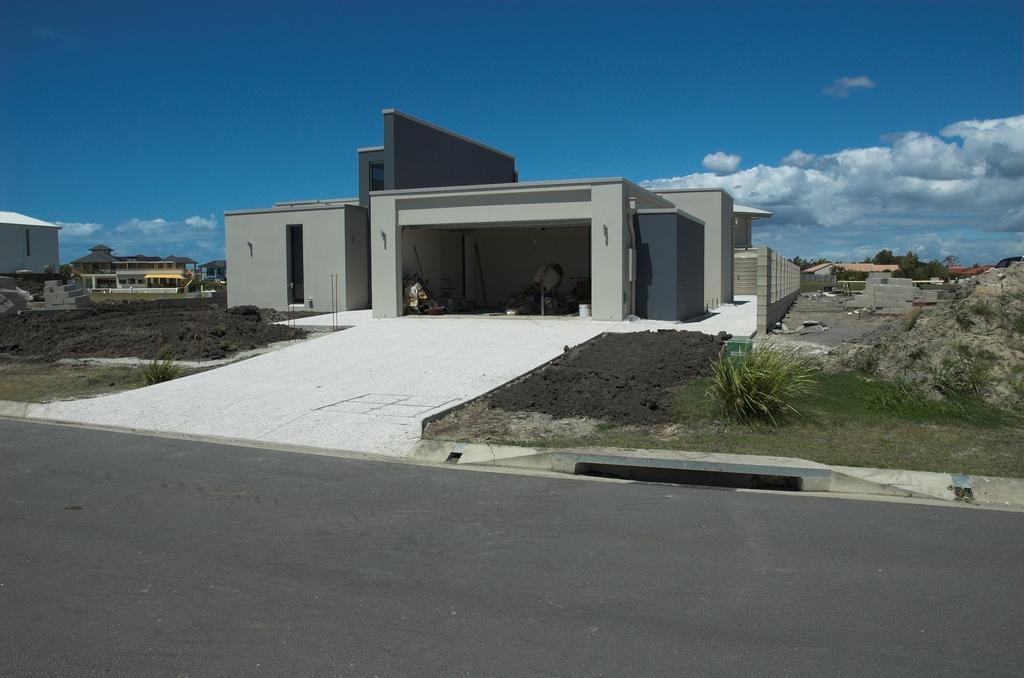Please provide a concise description of this image. In this image we can see few buildings, mud, road, trees and the sky with clouds in the background. 